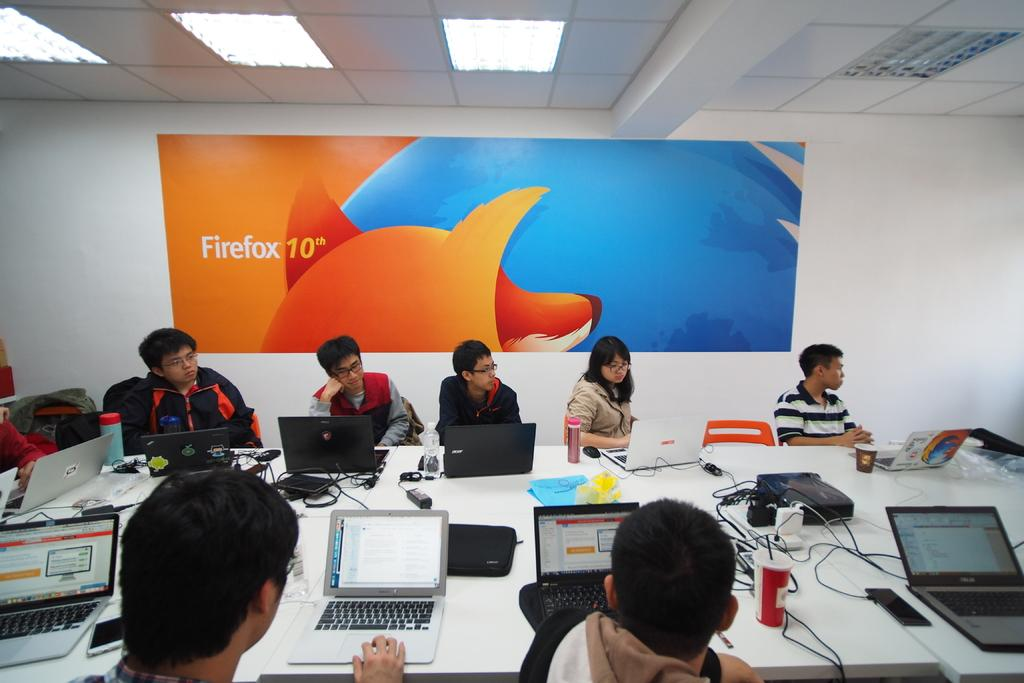<image>
Present a compact description of the photo's key features. Several people sitting around a conference room table with a sign behind them which reads Firefox 10. 